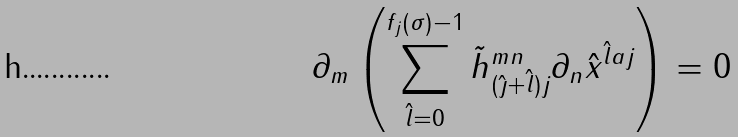Convert formula to latex. <formula><loc_0><loc_0><loc_500><loc_500>\partial _ { m } \left ( \sum _ { { \hat { l } } = 0 } ^ { f _ { j } ( \sigma ) - 1 } { \tilde { h } } _ { ( { \hat { \jmath } } + { \hat { l } } ) j } ^ { m n } \partial _ { n } { \hat { x } } ^ { { \hat { l } } a j } \right ) = 0</formula> 